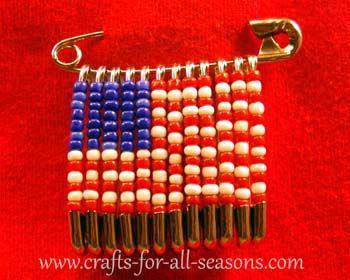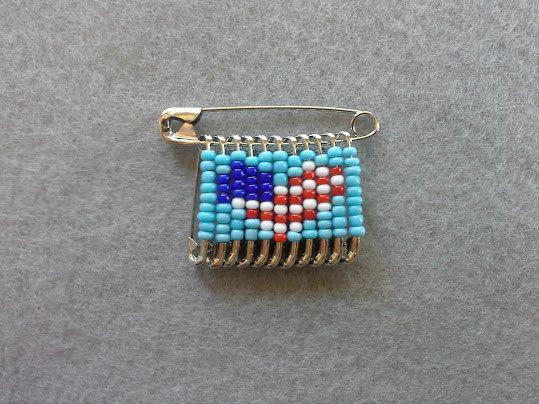The first image is the image on the left, the second image is the image on the right. Given the left and right images, does the statement "In one of the pictures, the beads are arranged to resemble an owl." hold true? Answer yes or no. No. The first image is the image on the left, the second image is the image on the right. Evaluate the accuracy of this statement regarding the images: "An image contains one pin jewelry with colored beads strung on silver safety pins to create a cartoon-like owl image.". Is it true? Answer yes or no. No. 